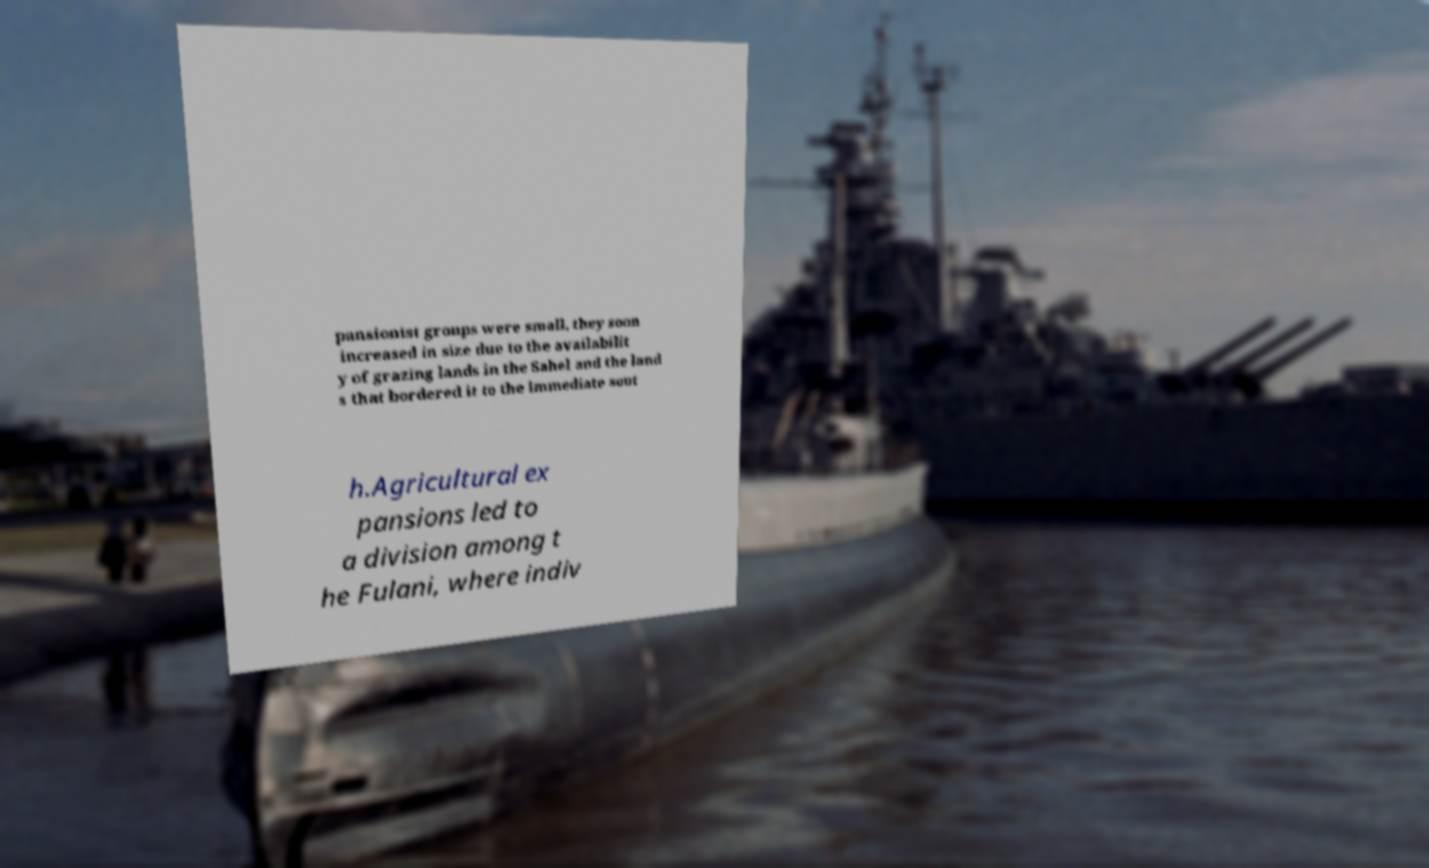Could you assist in decoding the text presented in this image and type it out clearly? pansionist groups were small, they soon increased in size due to the availabilit y of grazing lands in the Sahel and the land s that bordered it to the immediate sout h.Agricultural ex pansions led to a division among t he Fulani, where indiv 